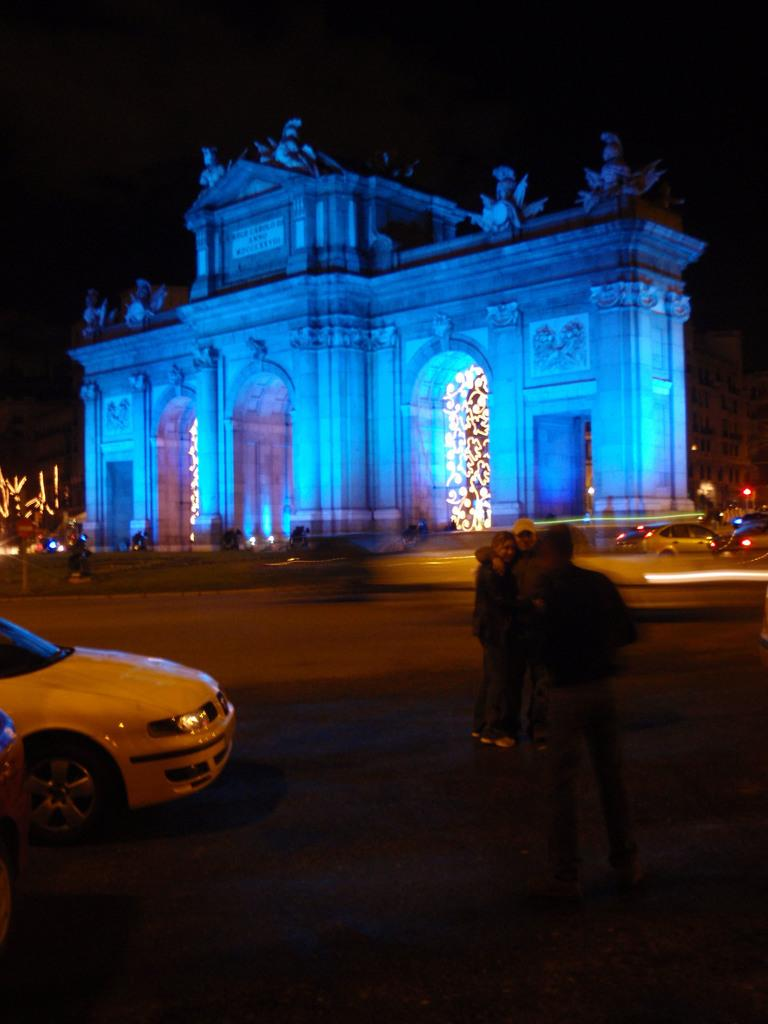What is the main structure in the center of the image? There is a building in the center of the image. What is located at the bottom of the image? There is a road at the bottom of the image. What type of vehicles can be seen in the image? There are cars visible in the image. Are there any people present in the image? Yes, there are people standing in the image. What type of stage can be seen in the image? There is no stage present in the image. How do the people in the image express disgust? The image does not show any expressions of disgust, nor is there any indication of such emotions. 